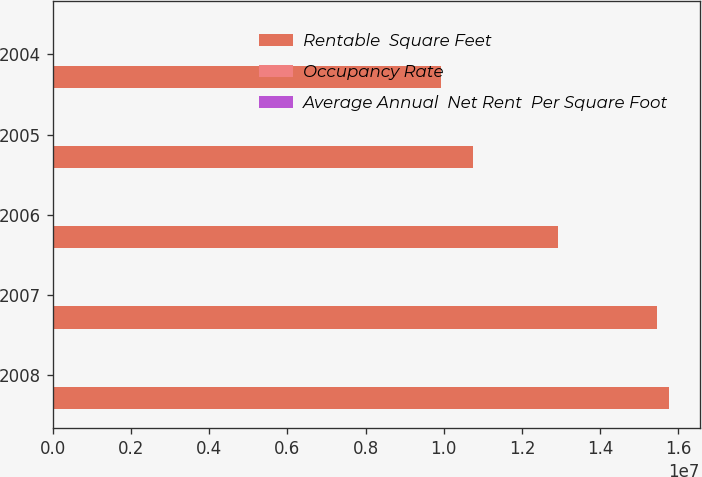Convert chart. <chart><loc_0><loc_0><loc_500><loc_500><stacked_bar_chart><ecel><fcel>2008<fcel>2007<fcel>2006<fcel>2005<fcel>2004<nl><fcel>Rentable  Square Feet<fcel>1.5755e+07<fcel>1.5463e+07<fcel>1.2933e+07<fcel>1.075e+07<fcel>9.931e+06<nl><fcel>Occupancy Rate<fcel>91.9<fcel>94.1<fcel>92.9<fcel>95.5<fcel>94.5<nl><fcel>Average Annual  Net Rent  Per Square Foot<fcel>14.52<fcel>14.12<fcel>13.48<fcel>12.07<fcel>12<nl></chart> 